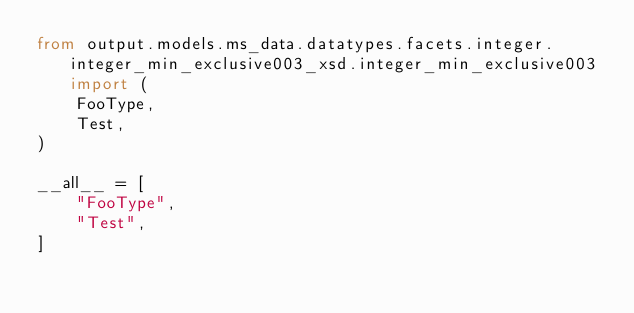Convert code to text. <code><loc_0><loc_0><loc_500><loc_500><_Python_>from output.models.ms_data.datatypes.facets.integer.integer_min_exclusive003_xsd.integer_min_exclusive003 import (
    FooType,
    Test,
)

__all__ = [
    "FooType",
    "Test",
]
</code> 